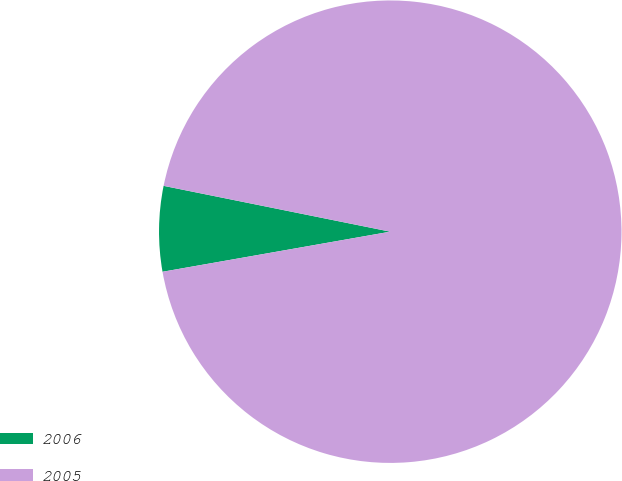Convert chart to OTSL. <chart><loc_0><loc_0><loc_500><loc_500><pie_chart><fcel>2006<fcel>2005<nl><fcel>5.95%<fcel>94.05%<nl></chart> 